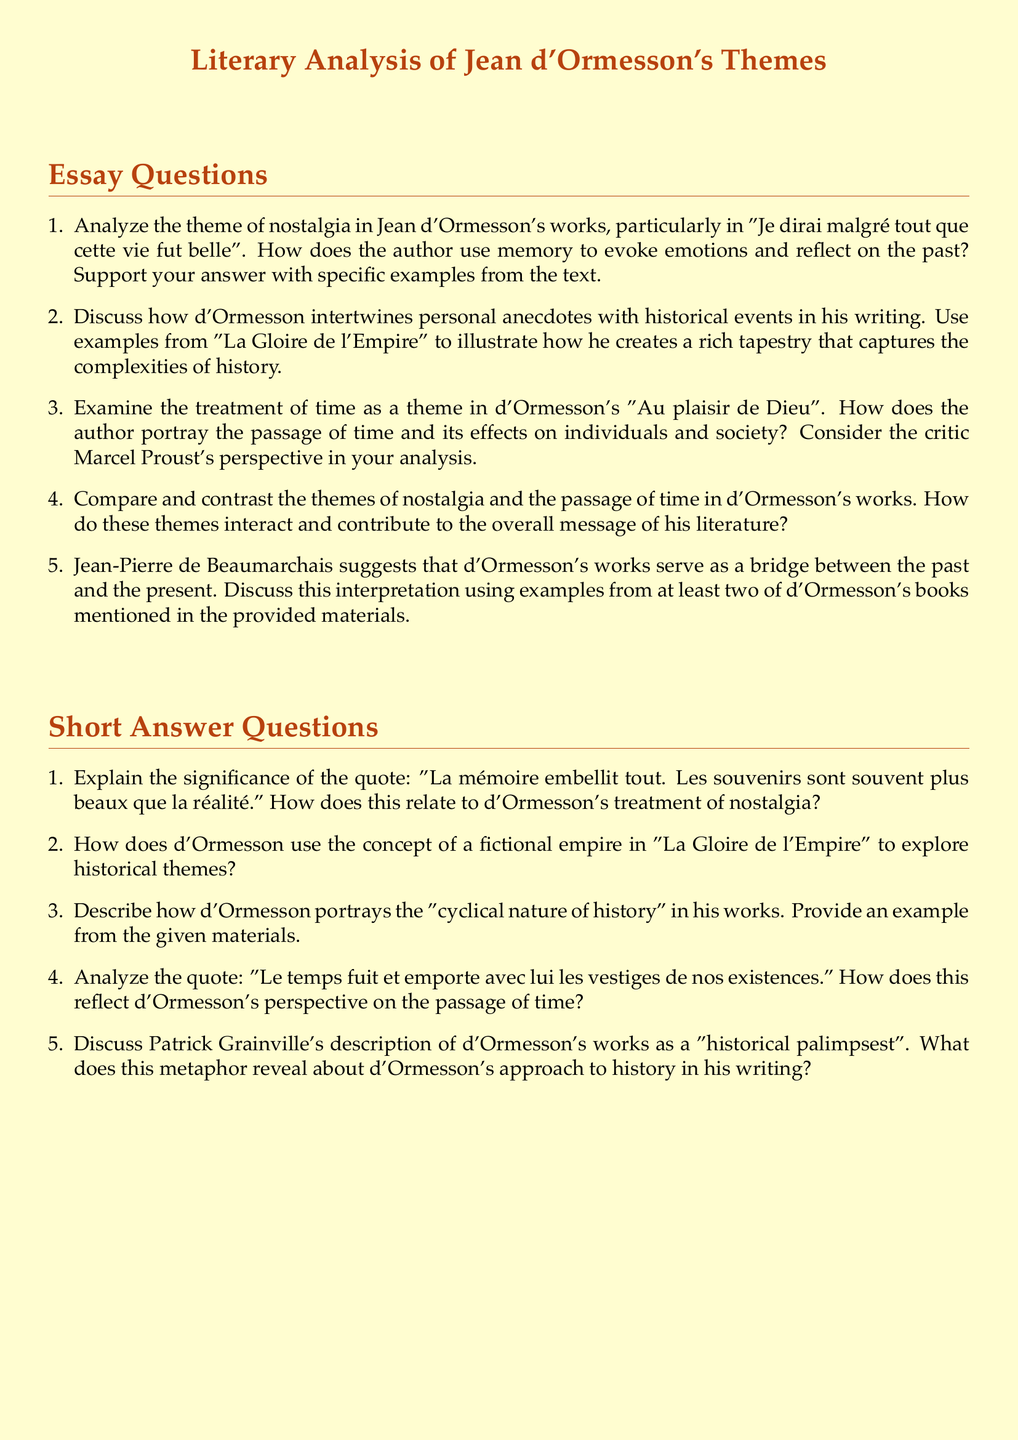What is the title of the essay section in the document? The title is presented at the beginning of the document as the main heading, indicating the focus on Jean d'Ormesson's themes.
Answer: Literary Analysis of Jean d'Ormesson Themes How many main essay questions are provided in the document? The document lists a total of five essay questions related to d'Ormesson's themes for analysis.
Answer: Five Which work of d'Ormesson is mentioned in connection with the theme of nostalgia? The document specifies this work in relation to the theme of nostalgia, asking for analysis of its depiction of memory and emotions from the past.
Answer: Je dirai malgré tout que cette vie fut belle What metaphor does Patrick Grainville use to describe d'Ormesson's works? The metaphor suggests a layered historical approach, which reflects on how d'Ormesson intertwines past and present in his narratives.
Answer: Historical palimpsest What is a key theme explored in "Au plaisir de Dieu" according to the document? The document refers to this theme, focusing on how d'Ormesson presents time and its effects in this work.
Answer: The passage of time 